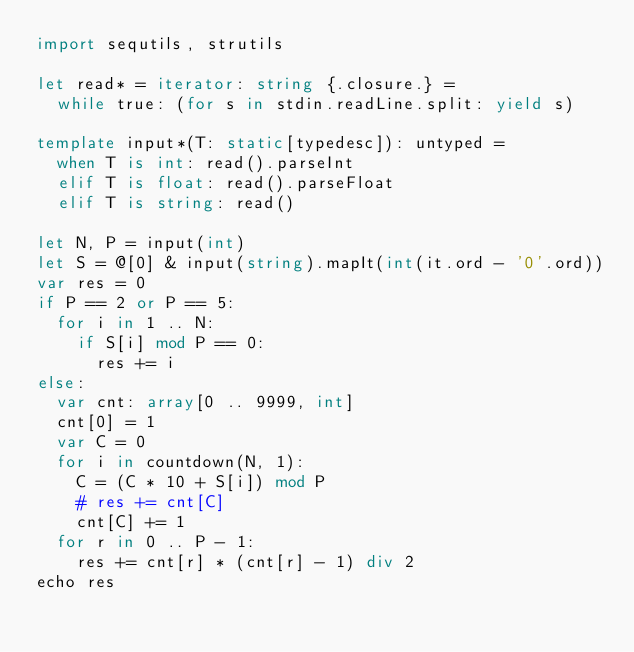Convert code to text. <code><loc_0><loc_0><loc_500><loc_500><_Nim_>import sequtils, strutils

let read* = iterator: string {.closure.} =
  while true: (for s in stdin.readLine.split: yield s)

template input*(T: static[typedesc]): untyped = 
  when T is int: read().parseInt
  elif T is float: read().parseFloat
  elif T is string: read()

let N, P = input(int)
let S = @[0] & input(string).mapIt(int(it.ord - '0'.ord))
var res = 0
if P == 2 or P == 5:
  for i in 1 .. N:
    if S[i] mod P == 0:
      res += i
else:
  var cnt: array[0 .. 9999, int]
  cnt[0] = 1
  var C = 0
  for i in countdown(N, 1):
    C = (C * 10 + S[i]) mod P
    # res += cnt[C]
    cnt[C] += 1
  for r in 0 .. P - 1:
    res += cnt[r] * (cnt[r] - 1) div 2
echo res</code> 